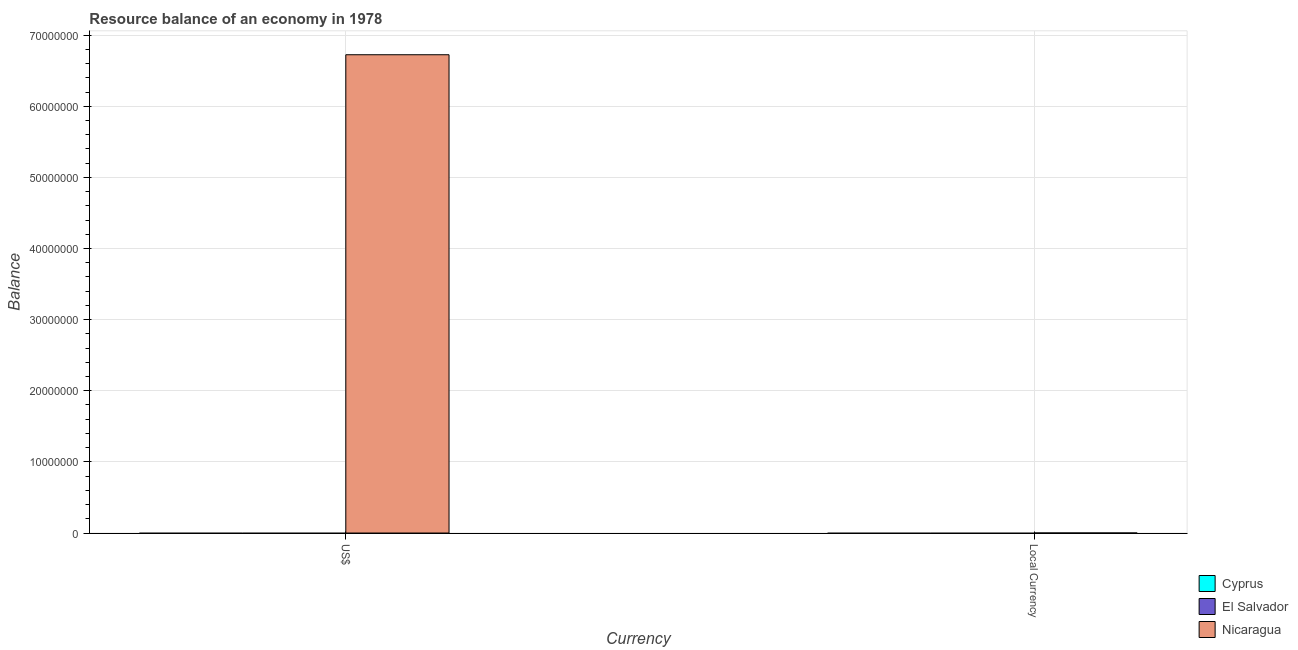How many different coloured bars are there?
Provide a short and direct response. 1. Are the number of bars per tick equal to the number of legend labels?
Your answer should be very brief. No. How many bars are there on the 1st tick from the right?
Make the answer very short. 1. What is the label of the 2nd group of bars from the left?
Your answer should be compact. Local Currency. What is the resource balance in us$ in Cyprus?
Provide a succinct answer. 0. Across all countries, what is the maximum resource balance in us$?
Give a very brief answer. 6.72e+07. In which country was the resource balance in us$ maximum?
Offer a terse response. Nicaragua. What is the total resource balance in constant us$ in the graph?
Offer a very short reply. 0.09. What is the average resource balance in us$ per country?
Provide a succinct answer. 2.24e+07. What is the difference between the resource balance in constant us$ and resource balance in us$ in Nicaragua?
Keep it short and to the point. -6.72e+07. In how many countries, is the resource balance in constant us$ greater than 30000000 units?
Offer a very short reply. 0. How many bars are there?
Give a very brief answer. 2. Are all the bars in the graph horizontal?
Ensure brevity in your answer.  No. How many countries are there in the graph?
Provide a short and direct response. 3. What is the difference between two consecutive major ticks on the Y-axis?
Offer a very short reply. 1.00e+07. Does the graph contain grids?
Provide a succinct answer. Yes. Where does the legend appear in the graph?
Give a very brief answer. Bottom right. How are the legend labels stacked?
Make the answer very short. Vertical. What is the title of the graph?
Offer a terse response. Resource balance of an economy in 1978. Does "Iran" appear as one of the legend labels in the graph?
Your response must be concise. No. What is the label or title of the X-axis?
Your answer should be compact. Currency. What is the label or title of the Y-axis?
Your answer should be compact. Balance. What is the Balance in El Salvador in US$?
Your answer should be very brief. 0. What is the Balance of Nicaragua in US$?
Your answer should be compact. 6.72e+07. What is the Balance in El Salvador in Local Currency?
Keep it short and to the point. 0. What is the Balance in Nicaragua in Local Currency?
Your answer should be very brief. 0.09. Across all Currency, what is the maximum Balance of Nicaragua?
Your response must be concise. 6.72e+07. Across all Currency, what is the minimum Balance in Nicaragua?
Keep it short and to the point. 0.09. What is the total Balance of Cyprus in the graph?
Give a very brief answer. 0. What is the total Balance of El Salvador in the graph?
Provide a succinct answer. 0. What is the total Balance of Nicaragua in the graph?
Offer a terse response. 6.72e+07. What is the difference between the Balance in Nicaragua in US$ and that in Local Currency?
Offer a terse response. 6.72e+07. What is the average Balance in Cyprus per Currency?
Provide a short and direct response. 0. What is the average Balance in El Salvador per Currency?
Provide a short and direct response. 0. What is the average Balance of Nicaragua per Currency?
Offer a very short reply. 3.36e+07. What is the ratio of the Balance of Nicaragua in US$ to that in Local Currency?
Keep it short and to the point. 7.09e+08. What is the difference between the highest and the second highest Balance of Nicaragua?
Your answer should be compact. 6.72e+07. What is the difference between the highest and the lowest Balance of Nicaragua?
Ensure brevity in your answer.  6.72e+07. 